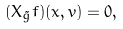Convert formula to latex. <formula><loc_0><loc_0><loc_500><loc_500>( X _ { \tilde { g } } f ) ( x , v ) = 0 ,</formula> 